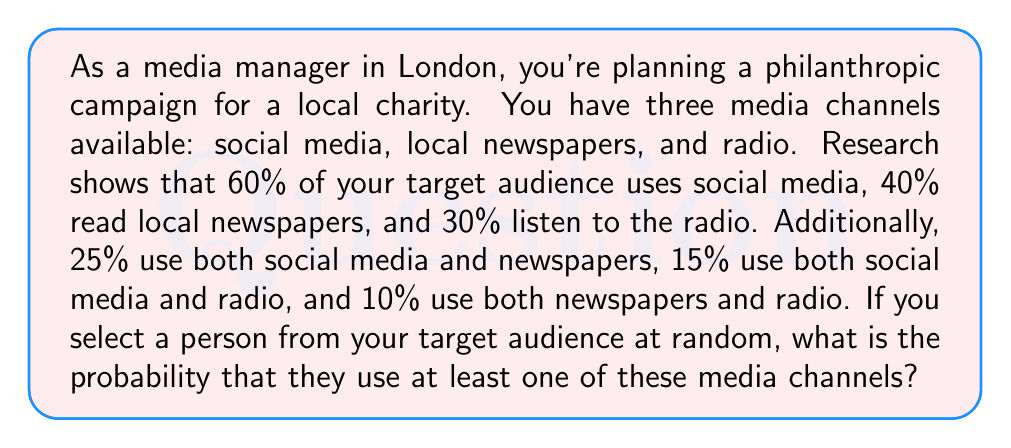Can you answer this question? Let's approach this step-by-step using the principle of inclusion-exclusion:

1) Let's define our events:
   S: uses social media
   N: reads newspapers
   R: listens to radio

2) We're given:
   $P(S) = 0.60$
   $P(N) = 0.40$
   $P(R) = 0.30$
   $P(S \cap N) = 0.25$
   $P(S \cap R) = 0.15$
   $P(N \cap R) = 0.10$

3) We need to find $P(S \cup N \cup R)$, which is the probability of using at least one channel.

4) The inclusion-exclusion principle for three sets states:

   $$P(S \cup N \cup R) = P(S) + P(N) + P(R) - P(S \cap N) - P(S \cap R) - P(N \cap R) + P(S \cap N \cap R)$$

5) We have all values except $P(S \cap N \cap R)$. We can find this using:

   $$P(S \cap N \cap R) = P(S) + P(N) + P(R) - P(S \cup N \cup R)$$

6) Since we don't know $P(S \cup N \cup R)$, we can't solve for $P(S \cap N \cap R)$ directly. However, we know it must be less than or equal to the smallest of $P(S \cap N)$, $P(S \cap R)$, and $P(N \cap R)$, which is 0.10.

7) Therefore, the probability of using at least one channel is at least:

   $$0.60 + 0.40 + 0.30 - 0.25 - 0.15 - 0.10 = 0.80$$

8) And at most:

   $$0.60 + 0.40 + 0.30 - 0.25 - 0.15 - 0.10 + 0.10 = 0.90$$

9) The actual probability lies between these two values, but we can't determine it precisely without more information.
Answer: Between 80% and 90% 